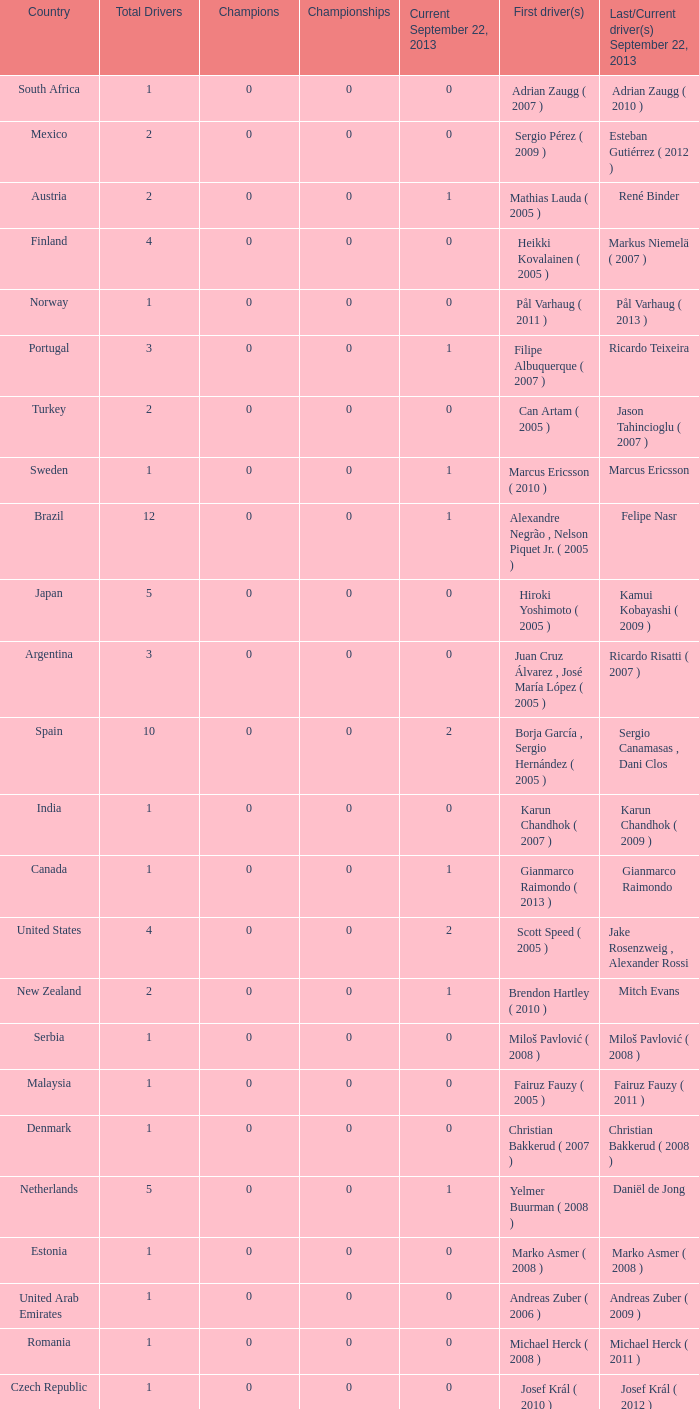How many champions were there when the last driver for September 22, 2013 was vladimir arabadzhiev ( 2010 )? 0.0. 